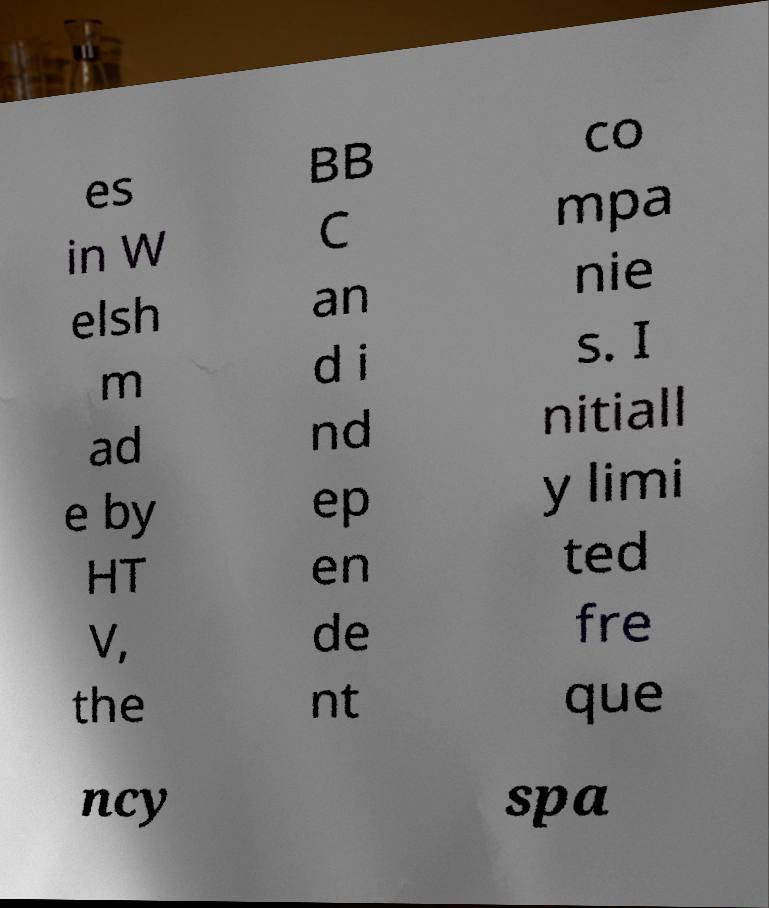Could you extract and type out the text from this image? es in W elsh m ad e by HT V, the BB C an d i nd ep en de nt co mpa nie s. I nitiall y limi ted fre que ncy spa 